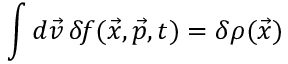<formula> <loc_0><loc_0><loc_500><loc_500>\int d \vec { v } \, \delta \, f ( \vec { x } , \vec { p } , t ) = \delta \rho ( \vec { x } )</formula> 